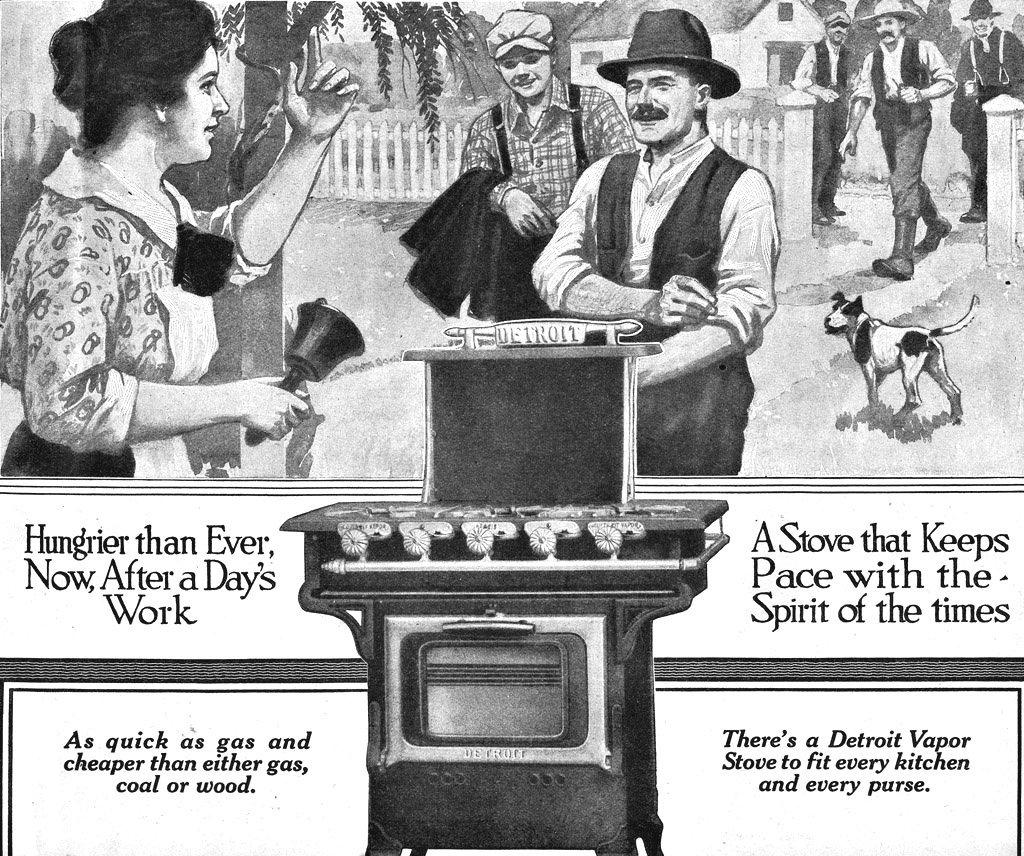<image>
Relay a brief, clear account of the picture shown. An advertisement for a Detroit Vapor Stove in black and white. 